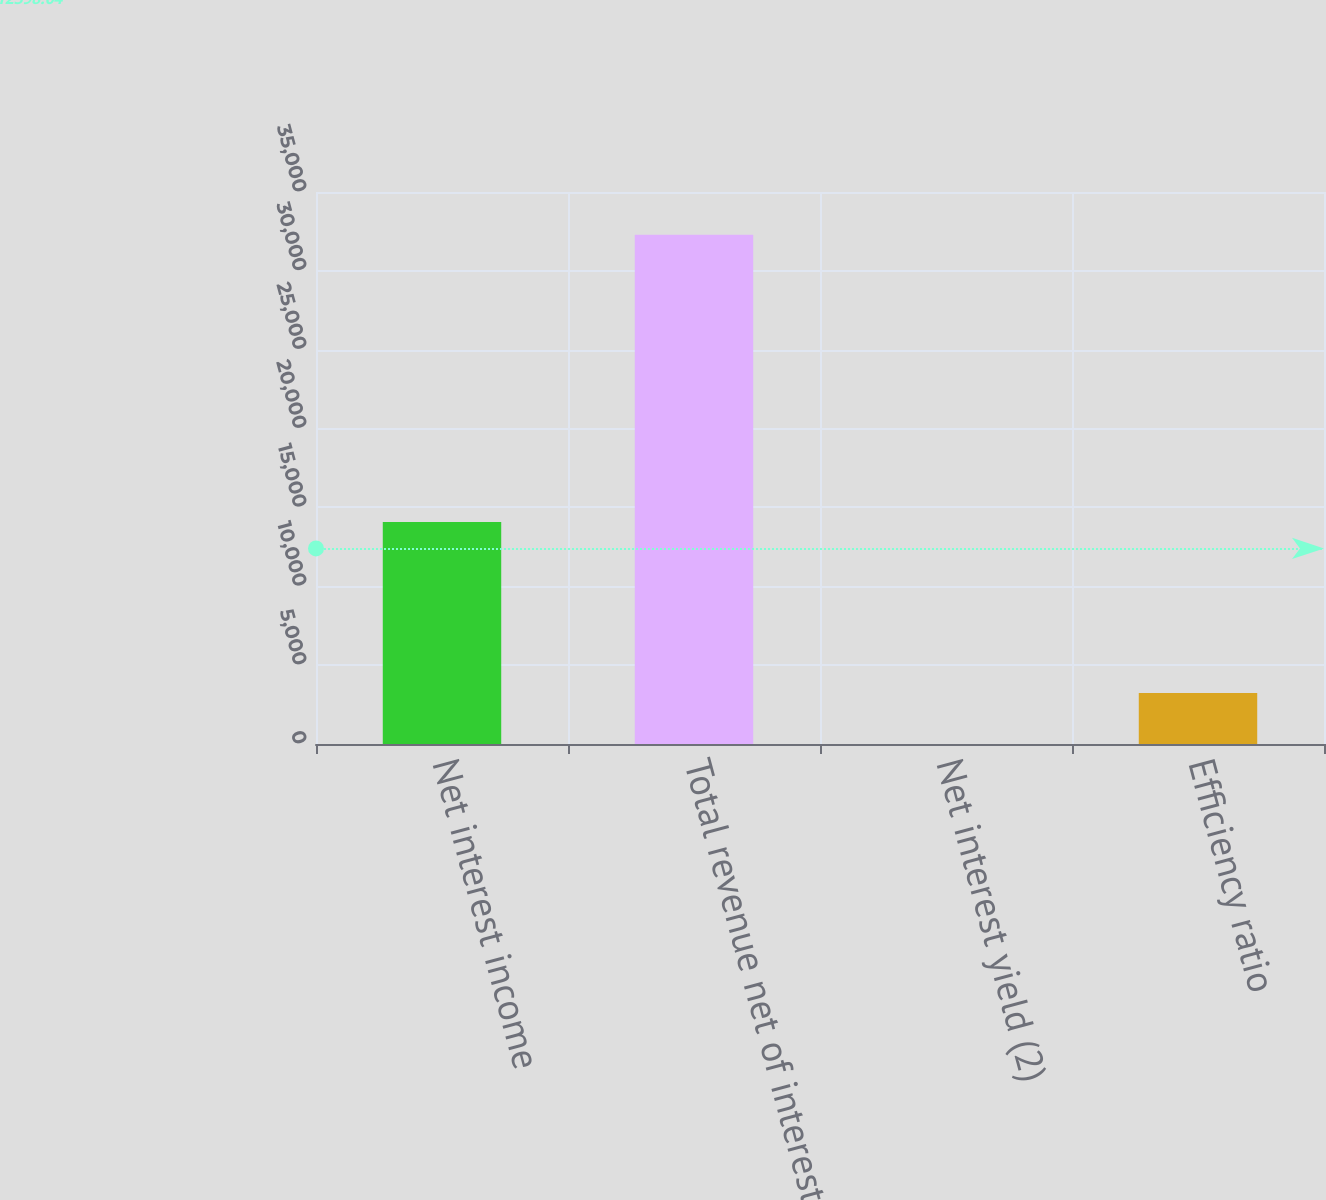<chart> <loc_0><loc_0><loc_500><loc_500><bar_chart><fcel>Net interest income<fcel>Total revenue net of interest<fcel>Net interest yield (2)<fcel>Efficiency ratio<nl><fcel>14070<fcel>32290<fcel>2.93<fcel>3231.64<nl></chart> 